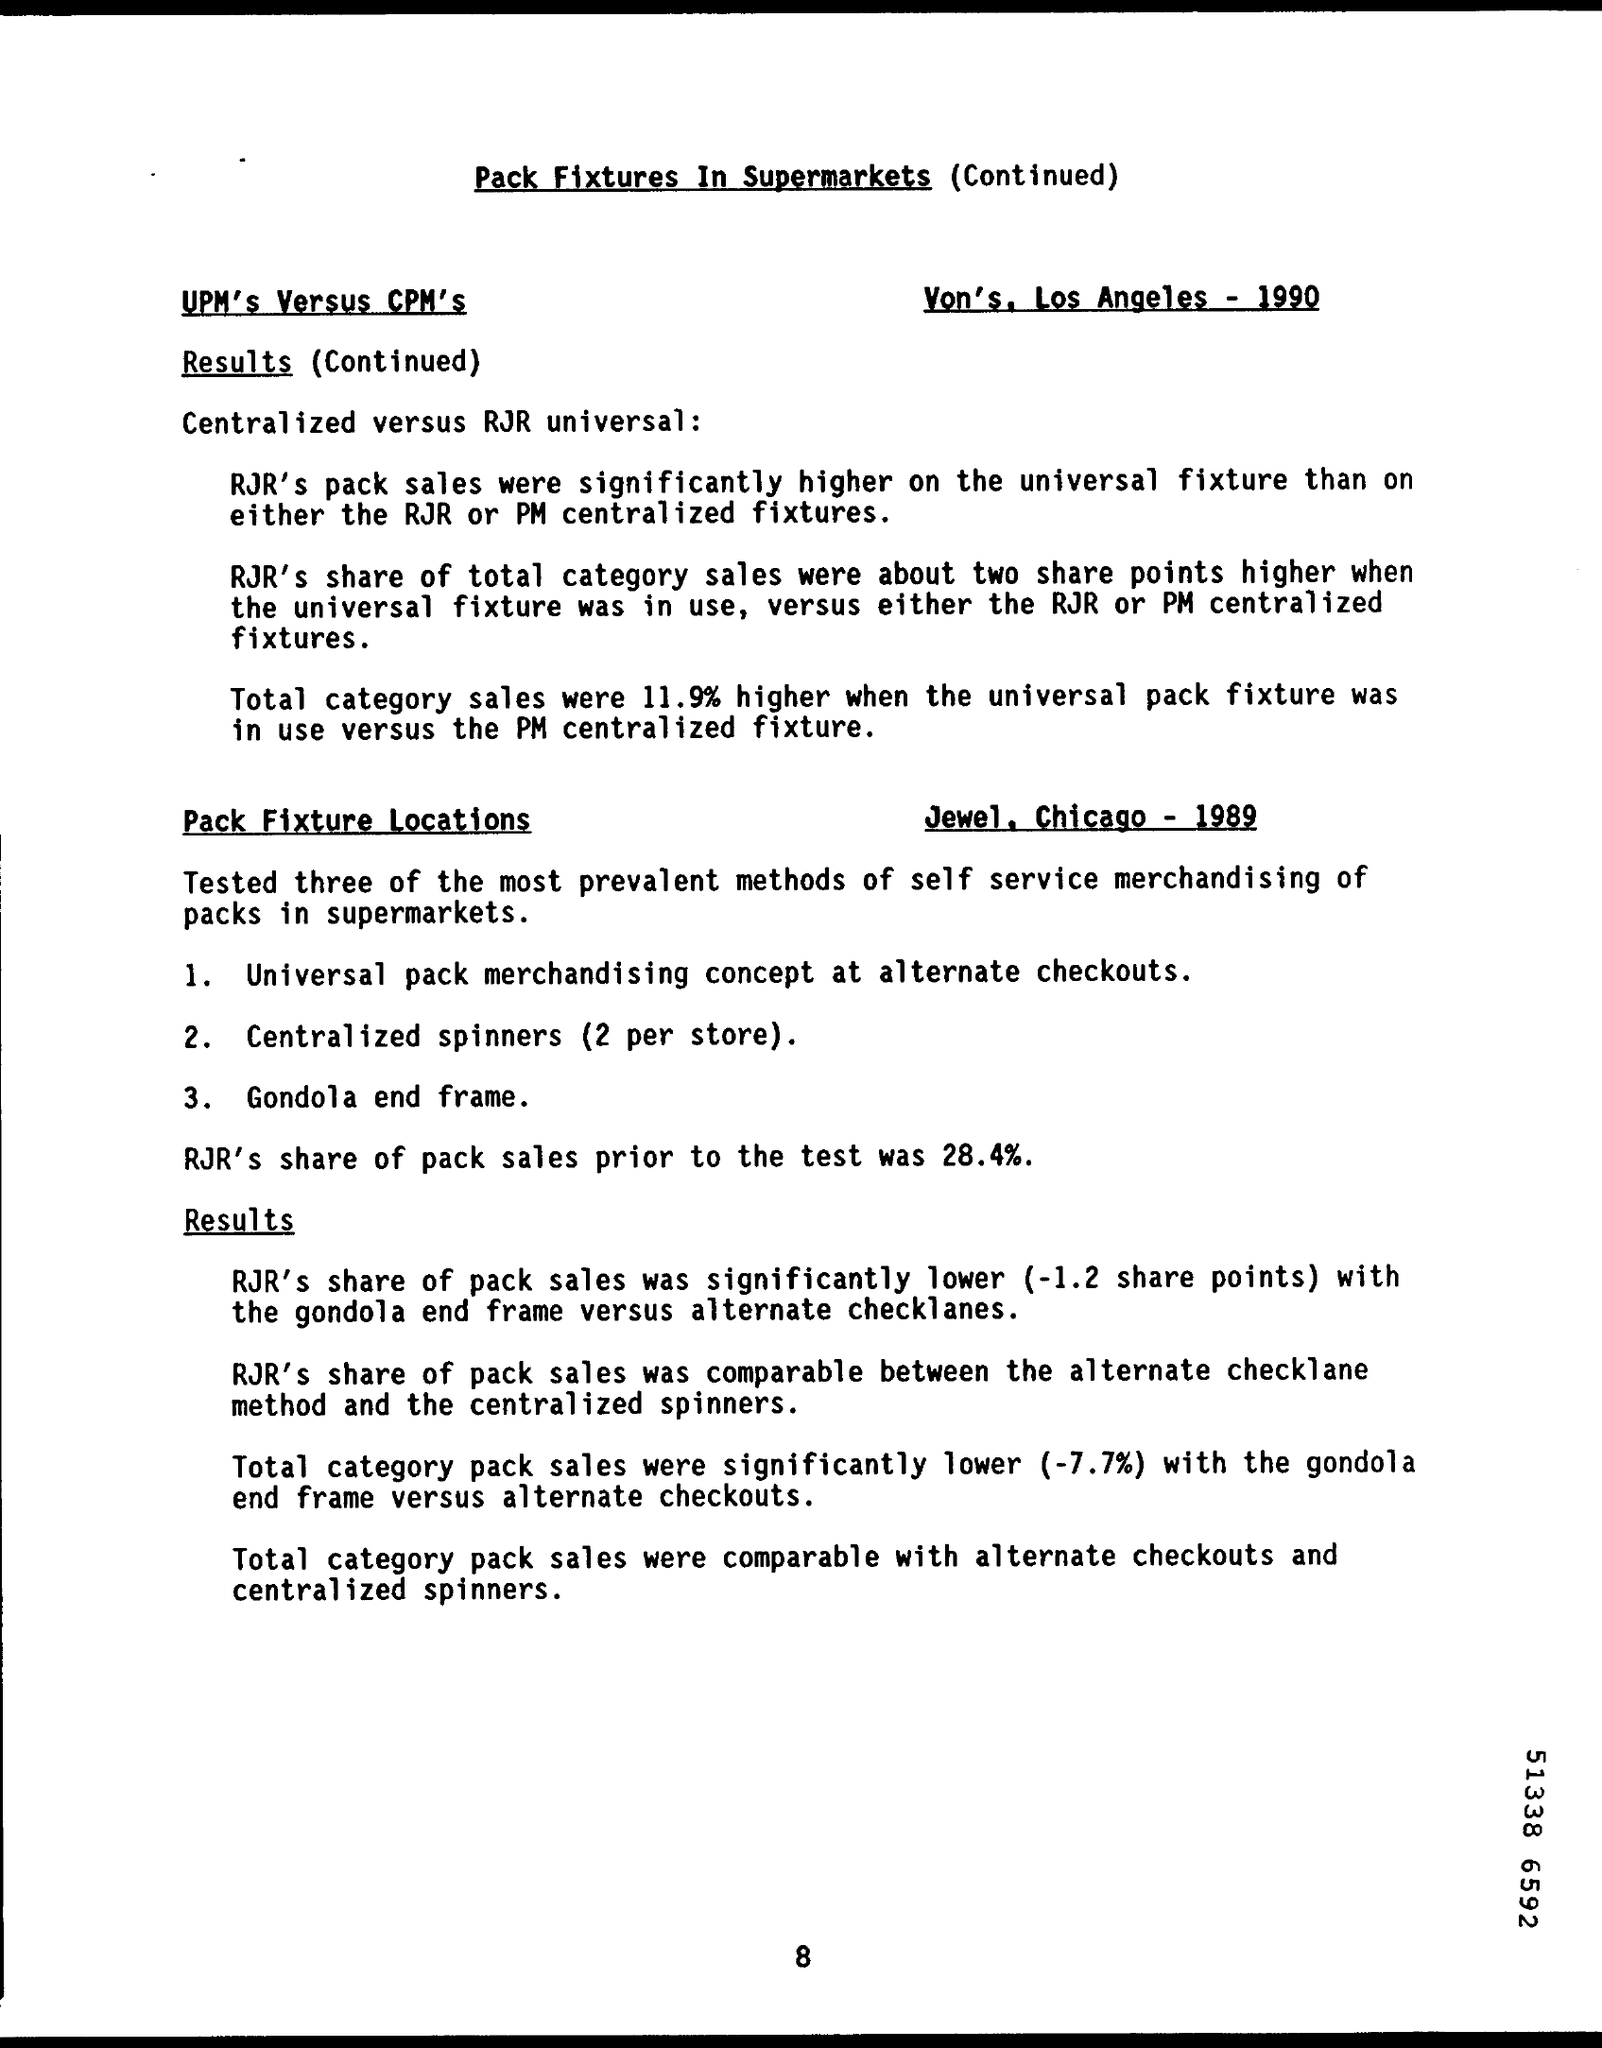Mention a couple of crucial points in this snapshot. The document title is "Pack Fixtures in Supermarkets". Prior to the test, RJR's share of the packaged cigarette sales was 28.4%. 